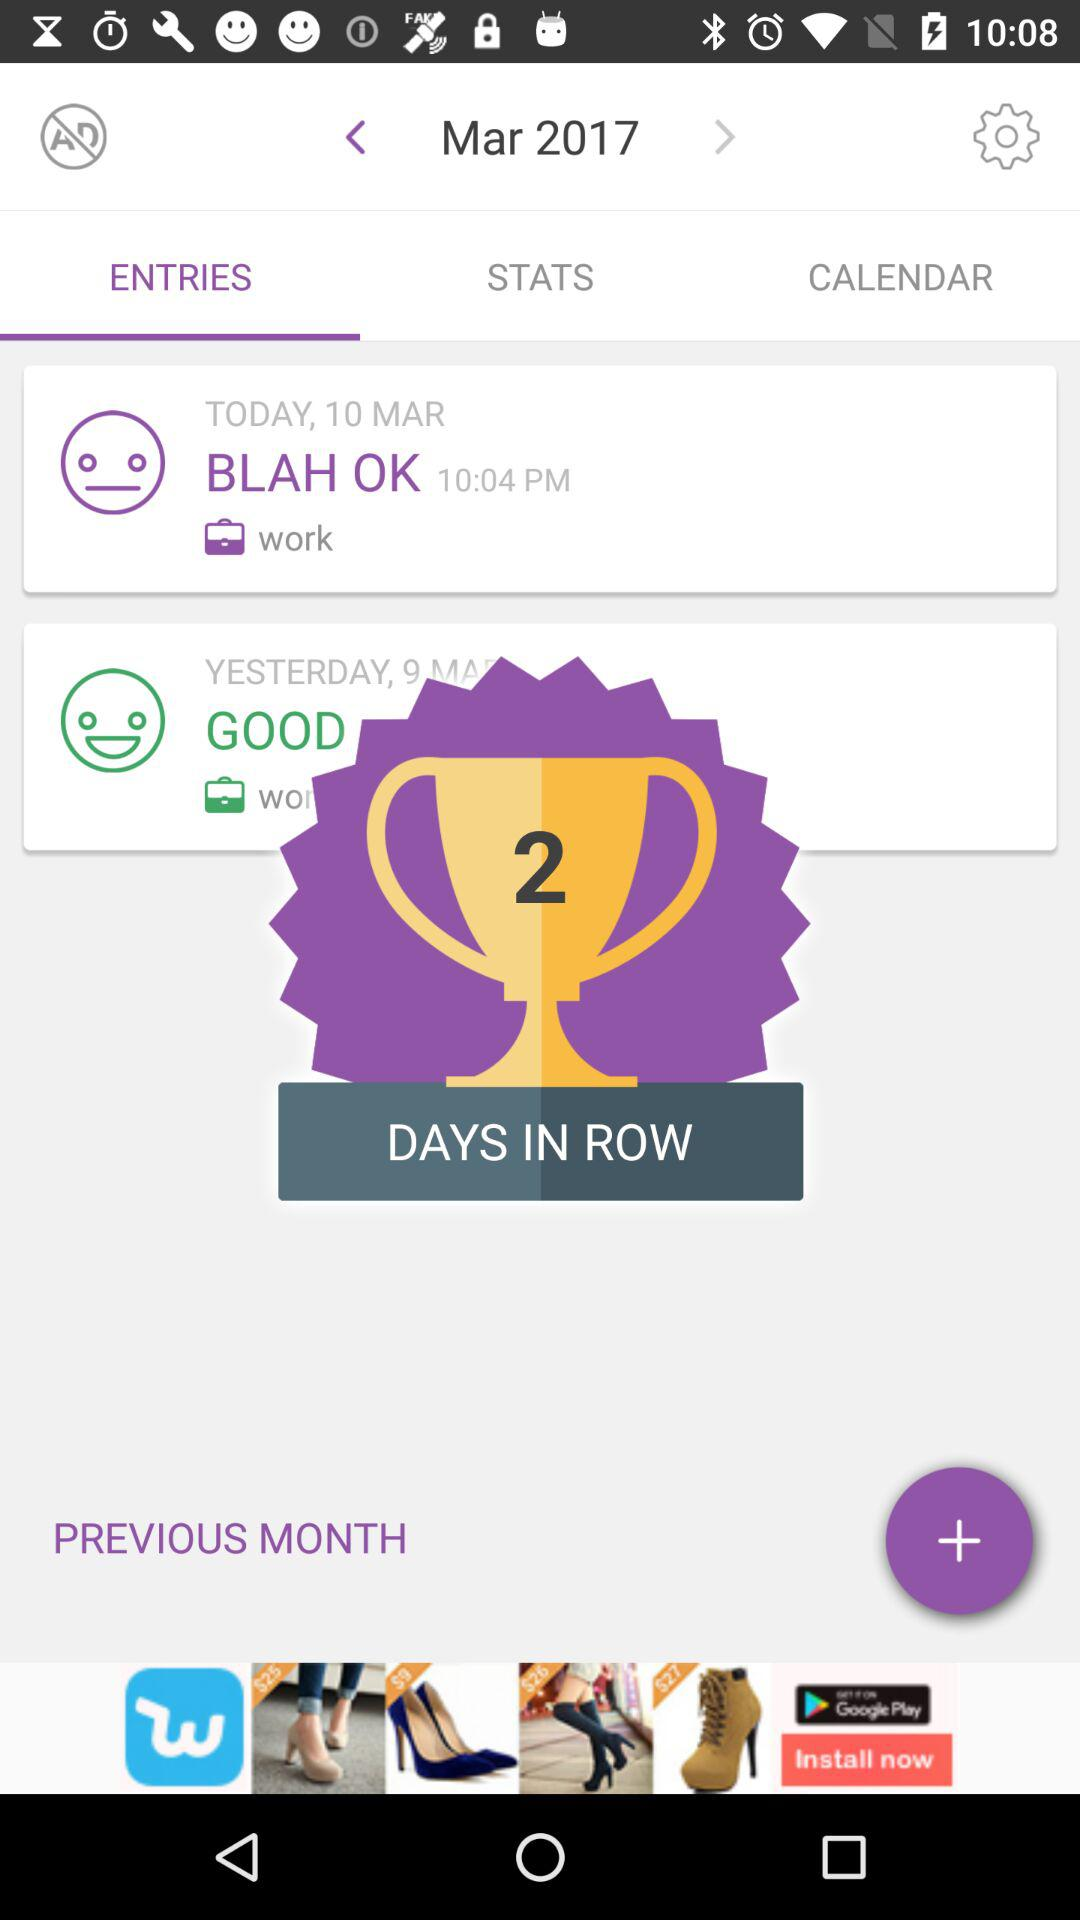What is the date of the entry "BLAH OK"? The date of the entry "BLAH OK" is March 10. 